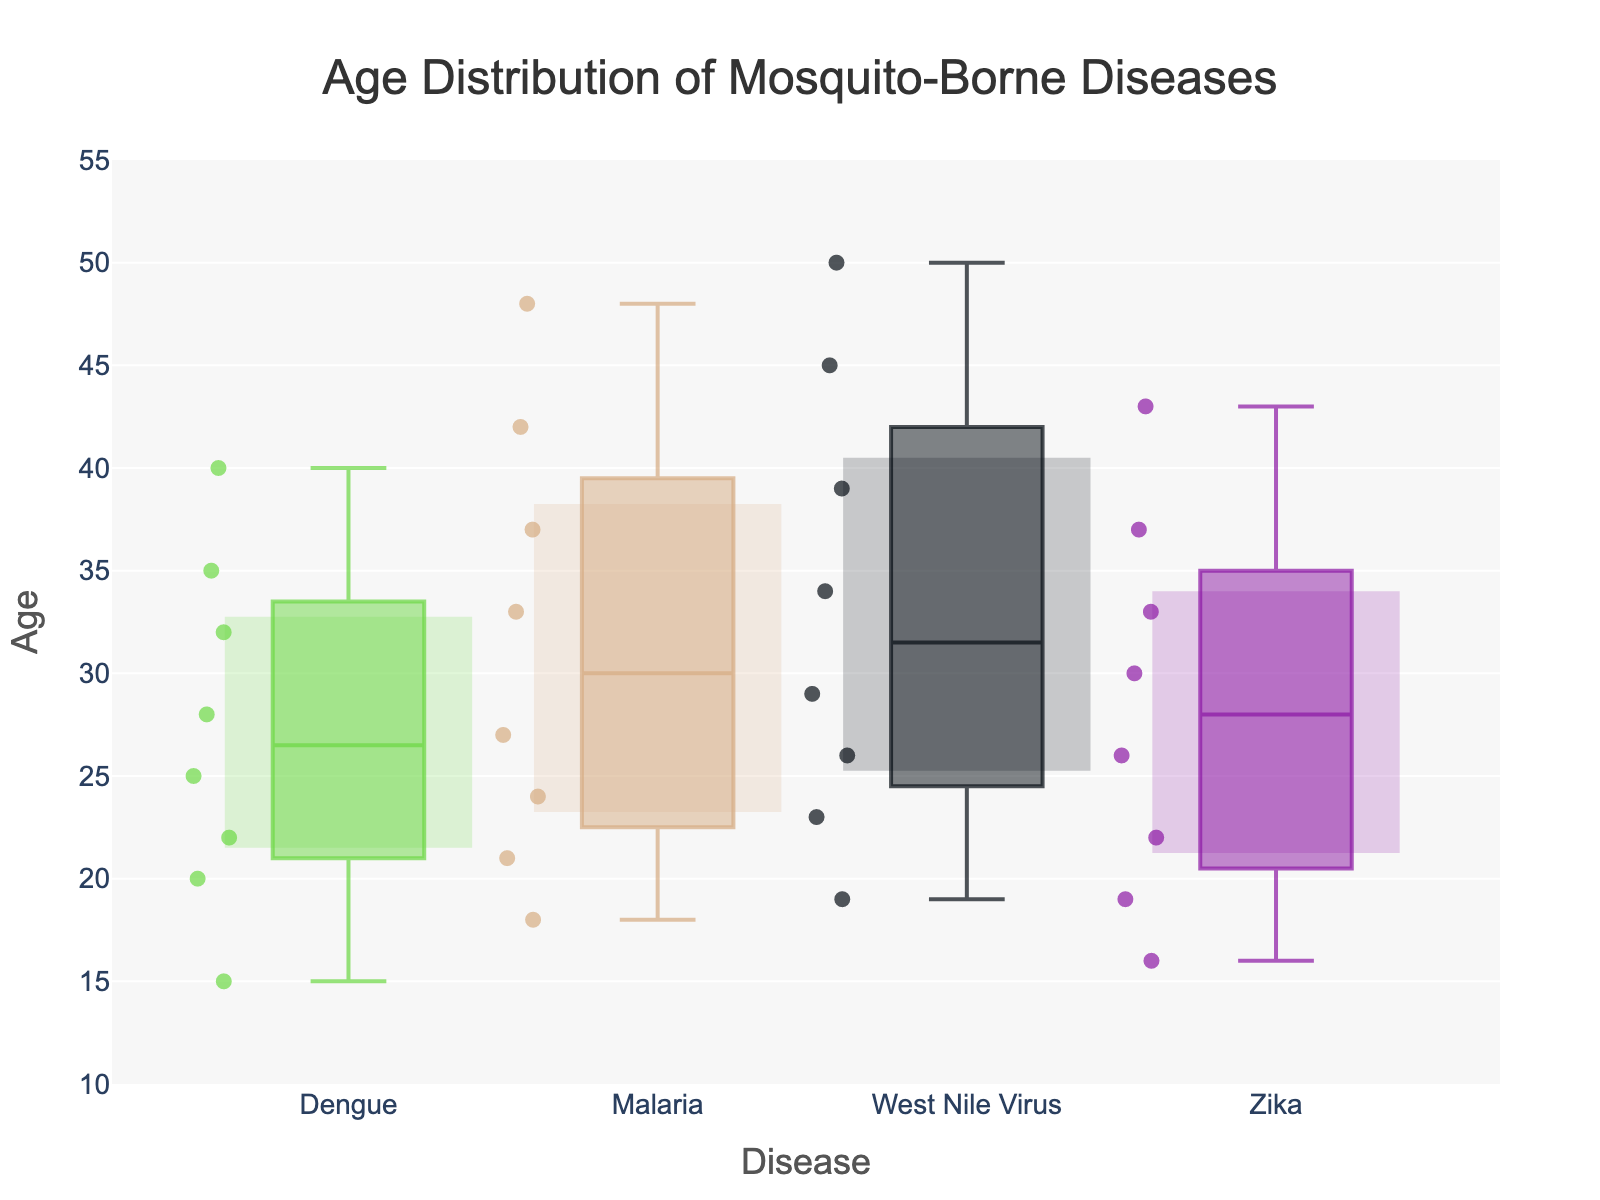What is the title of the figure? The title of the figure can be found at the top and typically provides a summary of what the plot is showing. In this case, it states the main point of the data being visualized.
Answer: Age Distribution of Mosquito-Borne Diseases Which disease has the highest median age? To find the disease with the highest median age, identify the line inside the box for each disease and see which one is at the highest position on the y-axis.
Answer: West Nile Virus What is the interquartile range (IQR) for Dengue? The IQR is the range between the first quartile (Q1) and the third quartile (Q3). For Dengue, identify the bottom and top of the box. The IQR can be read directly from the figure.
Answer: 10 years How many data points are there for Zika? Each dot within the box plot represents a data point. Count the number of dots for Zika to find the total number of data points.
Answer: 8 Which disease has the smallest range of ages? To determine this, examine the length of the whiskers for each disease. The disease with the shortest whiskers has the smallest range.
Answer: Zika What is the age range for Malaria? The range is calculated by subtracting the minimum age from the maximum age, which are represented by the bottom and top whiskers for Malaria.
Answer: 30 years Which disease has the most variability in age? The variability can be assessed by the length of the whiskers and the spread of the data points. The disease with the largest range (longest whiskers) shows the most variability.
Answer: West Nile Virus What is the median age for Zika? The median line inside the Zika box plot gives the median age directly. This is the line inside the box.
Answer: 26 years Between Dengue and Malaria, which one tends to affect younger individuals more frequently? Look at the position of the box plots on the y-axis. The lower the box plot is, the younger the age group it represents.
Answer: Dengue What is the maximum age for individuals affected by West Nile Virus based on the whiskers? The maximum age can be identified by the highest point the whisker reaches for West Nile Virus.
Answer: 50 years 